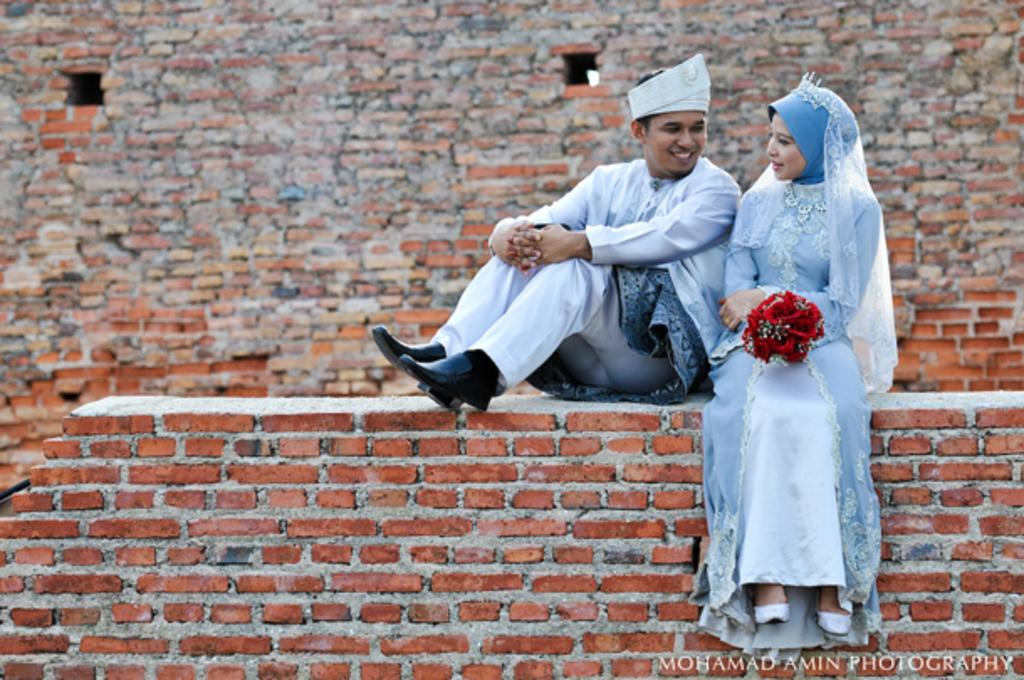Who is present in the image? There is a man and a woman in the image. What are the man and woman doing in the image? Both the man and woman are sitting on a brick wall in the image. What can be seen in the background of the image? There is a brick wall in the background of the image. Is there any text present in the image? Yes, there is text in the bottom right corner of the image. What type of flowers can be seen growing near the man and woman in the image? There are no flowers visible in the image; it only features a man, a woman, and a brick wall. What type of eggnog is being served to the man and woman in the image? There is no eggnog present in the image; it only features a man, a woman, and a brick wall. 